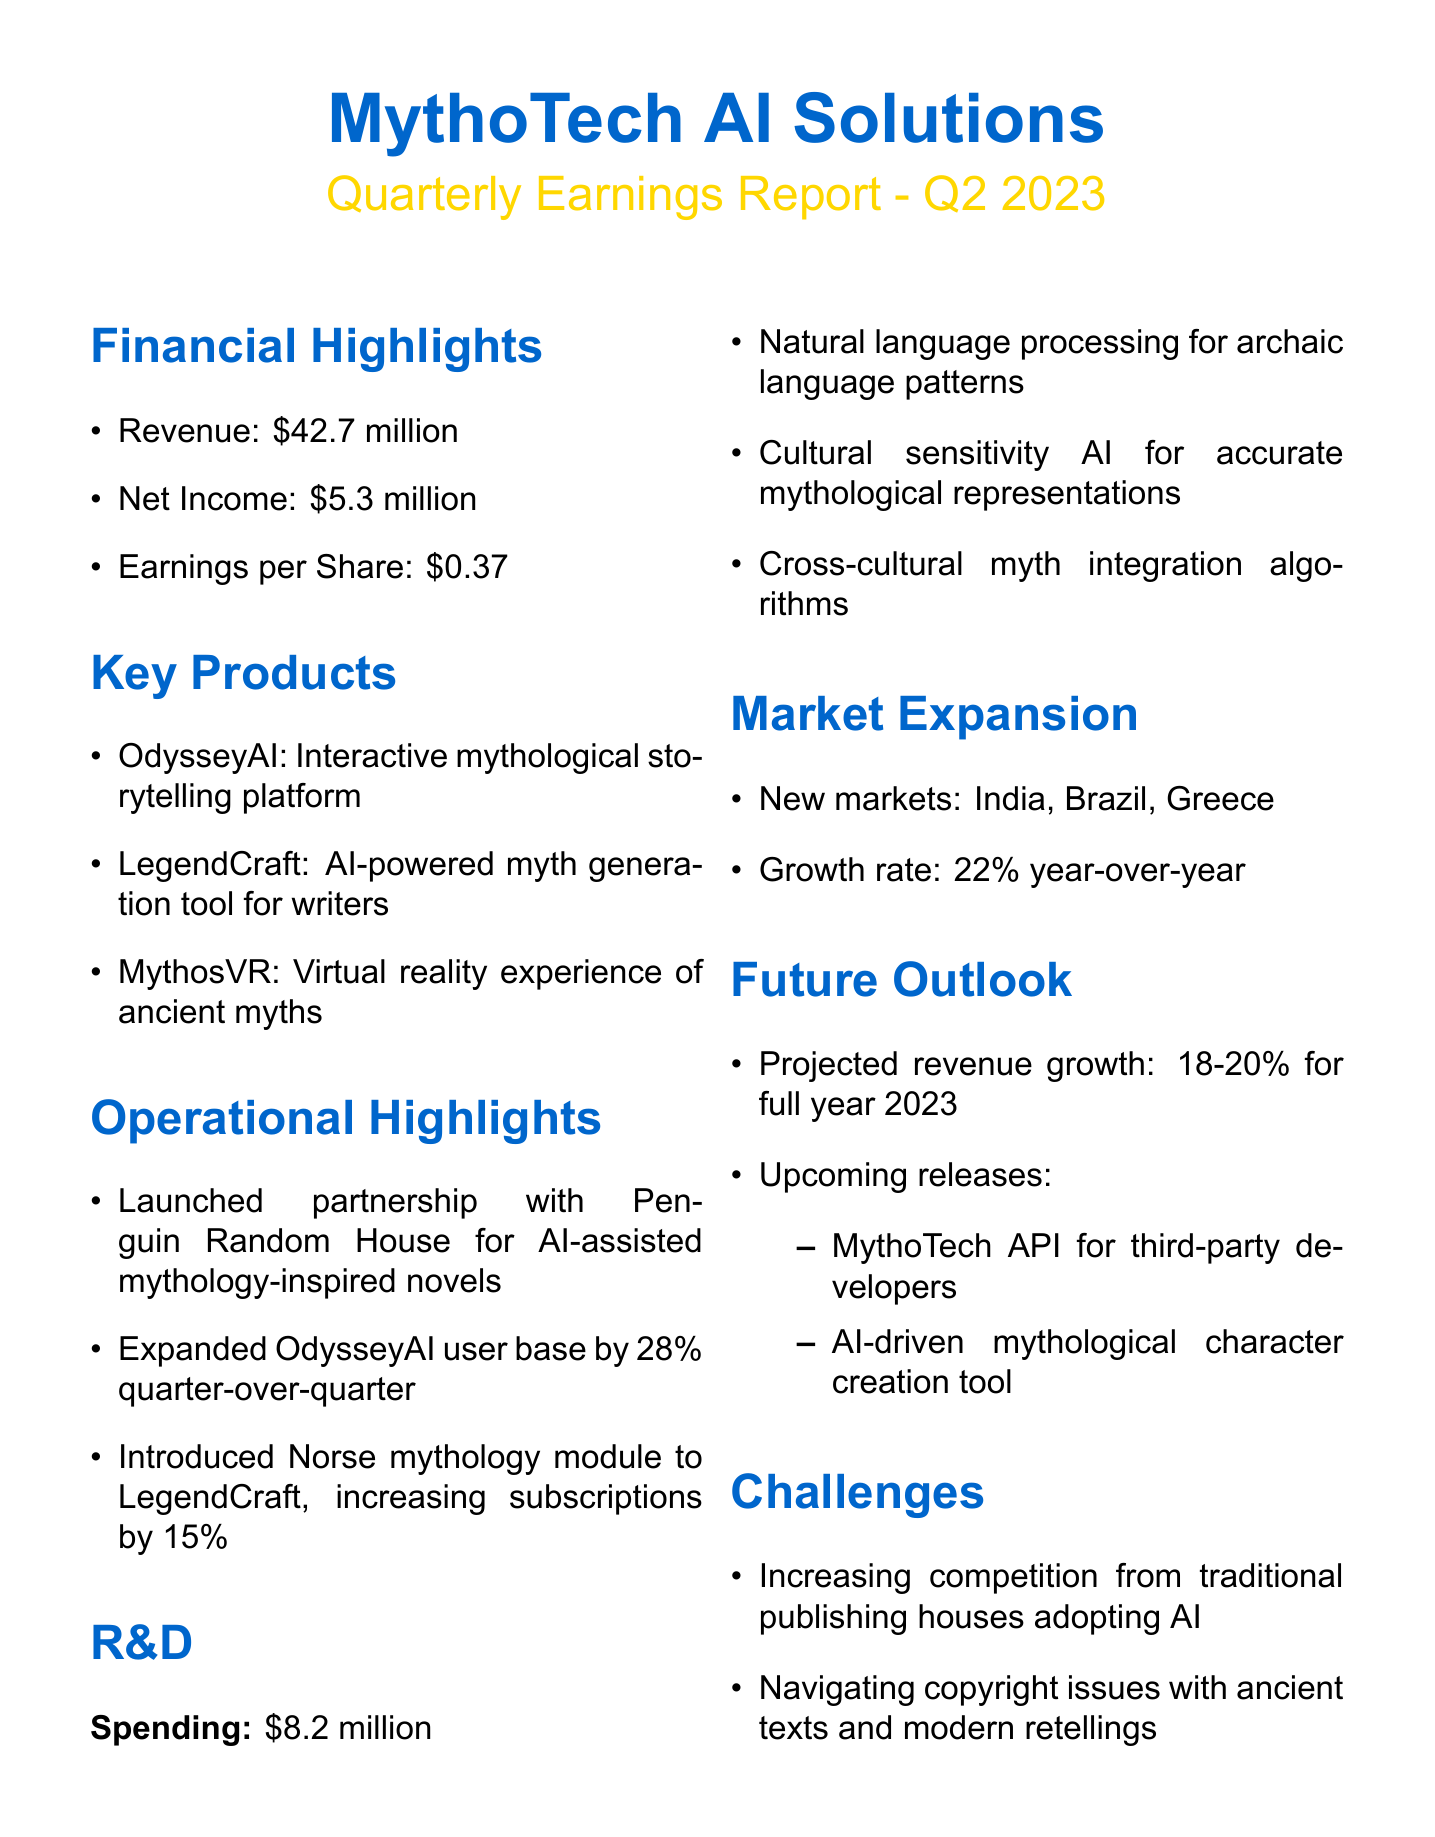what is the revenue for Q2 2023? The revenue for Q2 2023 is listed under financial highlights in the document as $42.7 million.
Answer: $42.7 million what is the net income of MythoTech AI Solutions? The net income is found in the financial highlights section, which states that it is $5.3 million for the quarter.
Answer: $5.3 million what are the key products offered by MythoTech AI Solutions? The key products are explicitly listed in the document, including OdysseyAI, LegendCraft, and MythosVR.
Answer: OdysseyAI, LegendCraft, MythosVR by what percentage did the OdysseyAI user base expand? The document states that the OdysseyAI user base expanded by 28% quarter-over-quarter.
Answer: 28% what was the spending on research and development? The research and development spending is detailed in the document and amounts to $8.2 million.
Answer: $8.2 million how many new markets did MythoTech expand into? The document indicates that MythoTech expanded into three new markets: India, Brazil, and Greece.
Answer: three what is the projected revenue growth for the full year 2023? The future outlook section specifies the projected revenue growth for the full year 2023 as 18-20%.
Answer: 18-20% what challenge does the company face regarding traditional publishing houses? The document mentions increasing competition as a challenge from traditional publishing houses that are adopting AI.
Answer: increasing competition what type of new release is planned for third-party developers? The future outlook details upcoming releases and includes a MythoTech API for third-party developers.
Answer: MythoTech API 